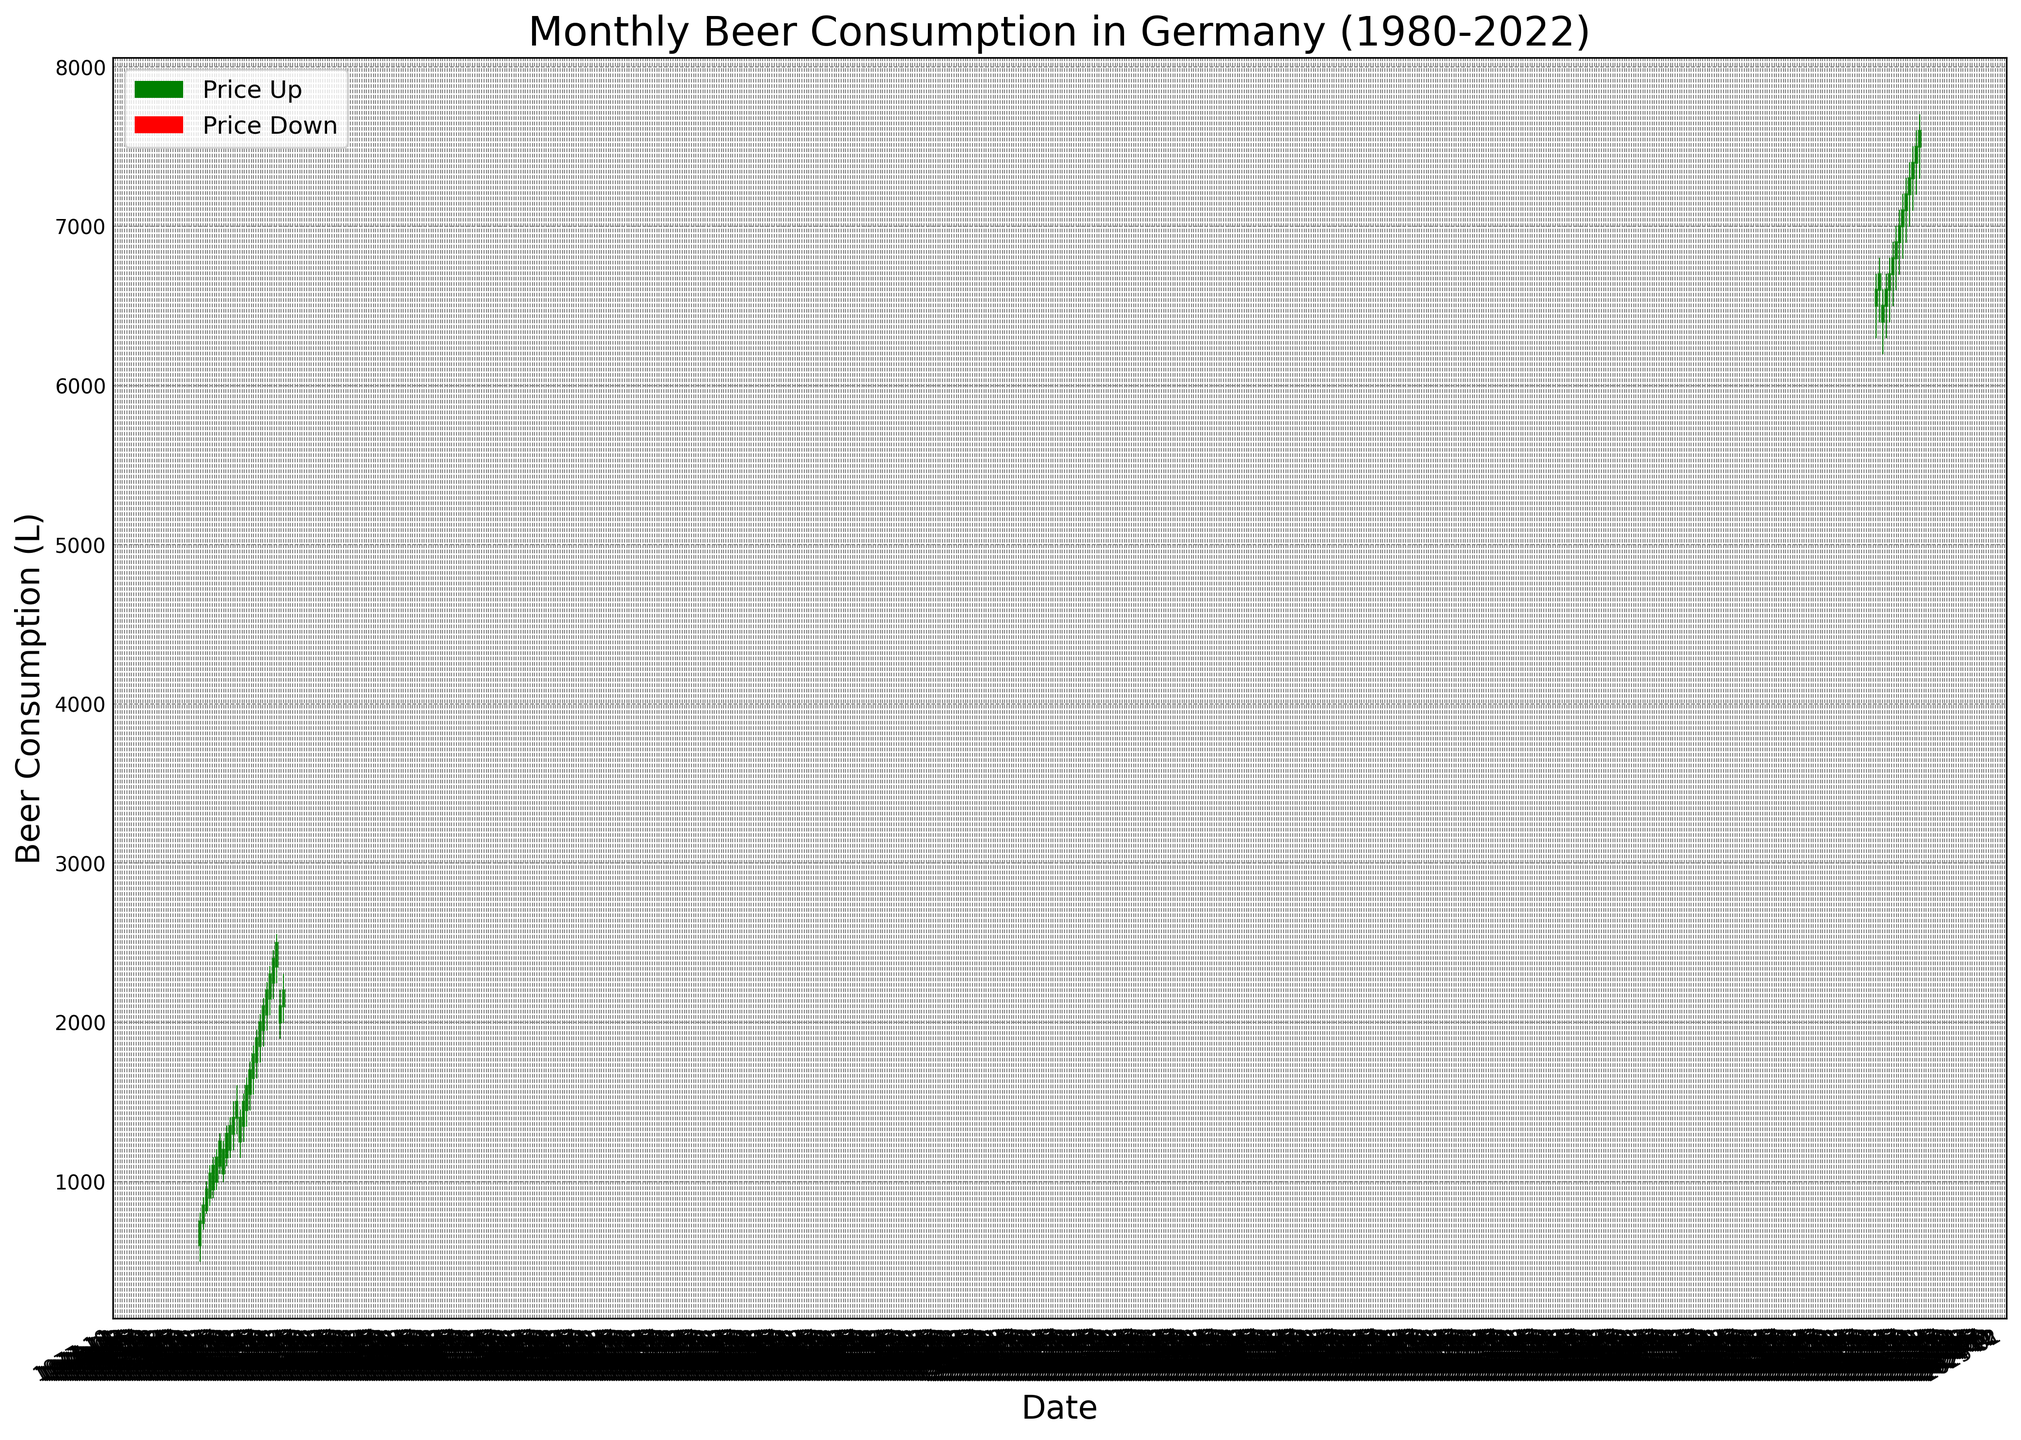What trend is observed in the beer consumption in Germany from January 1980 to December 1981? From January 1980 to December 1981, the beer consumption shows a general increasing trend. The candlestick highs and lows are progressively higher, indicating that both the highest and lowest monthly consumption levels increase over this period.
Answer: Increasing trend How does the closing value for September 1980 compare to the closing value in September 2022? The closing value for September 1980 is 1300, whereas the closing value for September 2022 is 7300. Comparing these values, September 2022's closing value is significantly higher.
Answer: September 2022's value is higher By how much did the highest monthly beer consumption change from November 1980 to November 2021? The highest monthly beer consumption in November 1980 was 1500, while in November 2021, it was 6700. The change in the highest monthly consumption is calculated as 6700 - 1500.
Answer: 5200 Are there more upward or downward trends in the candlesticks from 1980 to 1982? To determine this, we count the number of green and red candlesticks. From 1980 to 1982, there are 18 months, with a noticeable number of upward (green) candlesticks. Specifically, out of these, several months show green candlesticks indicating upward trends.
Answer: More upward trends Which month in 1980 showed the lowest beer consumption, and what was the value? To find the lowest value in 1980, we look at the 'Low' values of each month. January 1980 had the lowest beer consumption at a low of 500.
Answer: January 1980, 500 What is the average closing value for the year 2022? To calculate the average closing value for 2022, sum all the closing values from January 2022 to December 2022 and then divide by the number of months (12). The total closing values are 6500 + 6600 + 6700 + 6800 + 6900 + 7000 + 7100 + 7200 + 7300 + 7400 + 7500 + 7600, which equals 87600. Dividing this by 12 gives the average.
Answer: 7300 How did the closing value in December 1980 compare to January 1981? The closing value in December 1980 was 1500, and in January 1981, it was 1400. Therefore, there was a slight decrease from December 1980 to January 1981.
Answer: Decreased What months in 1981 showed a continuous upward trend in beer consumption? A continuous upward trend is shown by consecutive months with green candlesticks. Observing 1981, the months from January to July show continuous green candlesticks, indicating an upward trend throughout these months.
Answer: January to July Compare the highest beer consumption values between December 1980 and December 2022. In December 1980, the highest value was 1600, while in December 2022, it was 7700. Comparing these, December 2022’s highest value is significantly higher.
Answer: December 2022's value is higher 